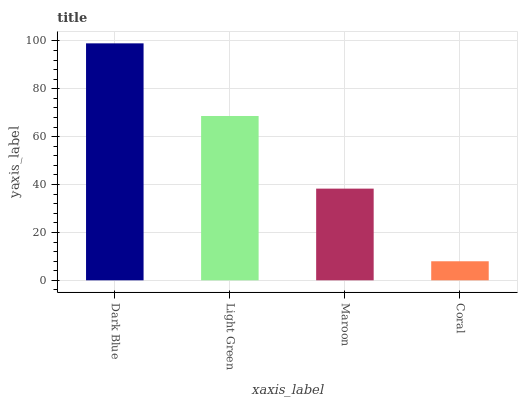Is Coral the minimum?
Answer yes or no. Yes. Is Dark Blue the maximum?
Answer yes or no. Yes. Is Light Green the minimum?
Answer yes or no. No. Is Light Green the maximum?
Answer yes or no. No. Is Dark Blue greater than Light Green?
Answer yes or no. Yes. Is Light Green less than Dark Blue?
Answer yes or no. Yes. Is Light Green greater than Dark Blue?
Answer yes or no. No. Is Dark Blue less than Light Green?
Answer yes or no. No. Is Light Green the high median?
Answer yes or no. Yes. Is Maroon the low median?
Answer yes or no. Yes. Is Maroon the high median?
Answer yes or no. No. Is Coral the low median?
Answer yes or no. No. 